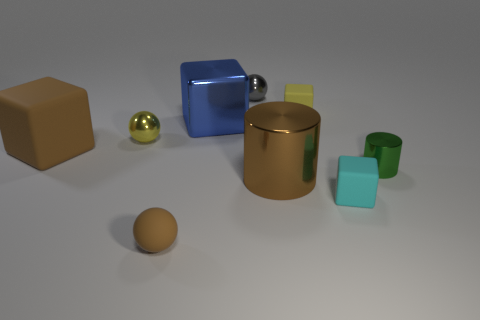Subtract all green cubes. Subtract all purple cylinders. How many cubes are left? 4 Add 1 brown metallic spheres. How many objects exist? 10 Subtract all blocks. How many objects are left? 5 Add 6 small shiny cylinders. How many small shiny cylinders exist? 7 Subtract 0 purple cubes. How many objects are left? 9 Subtract all tiny green things. Subtract all cyan objects. How many objects are left? 7 Add 6 small gray metallic things. How many small gray metallic things are left? 7 